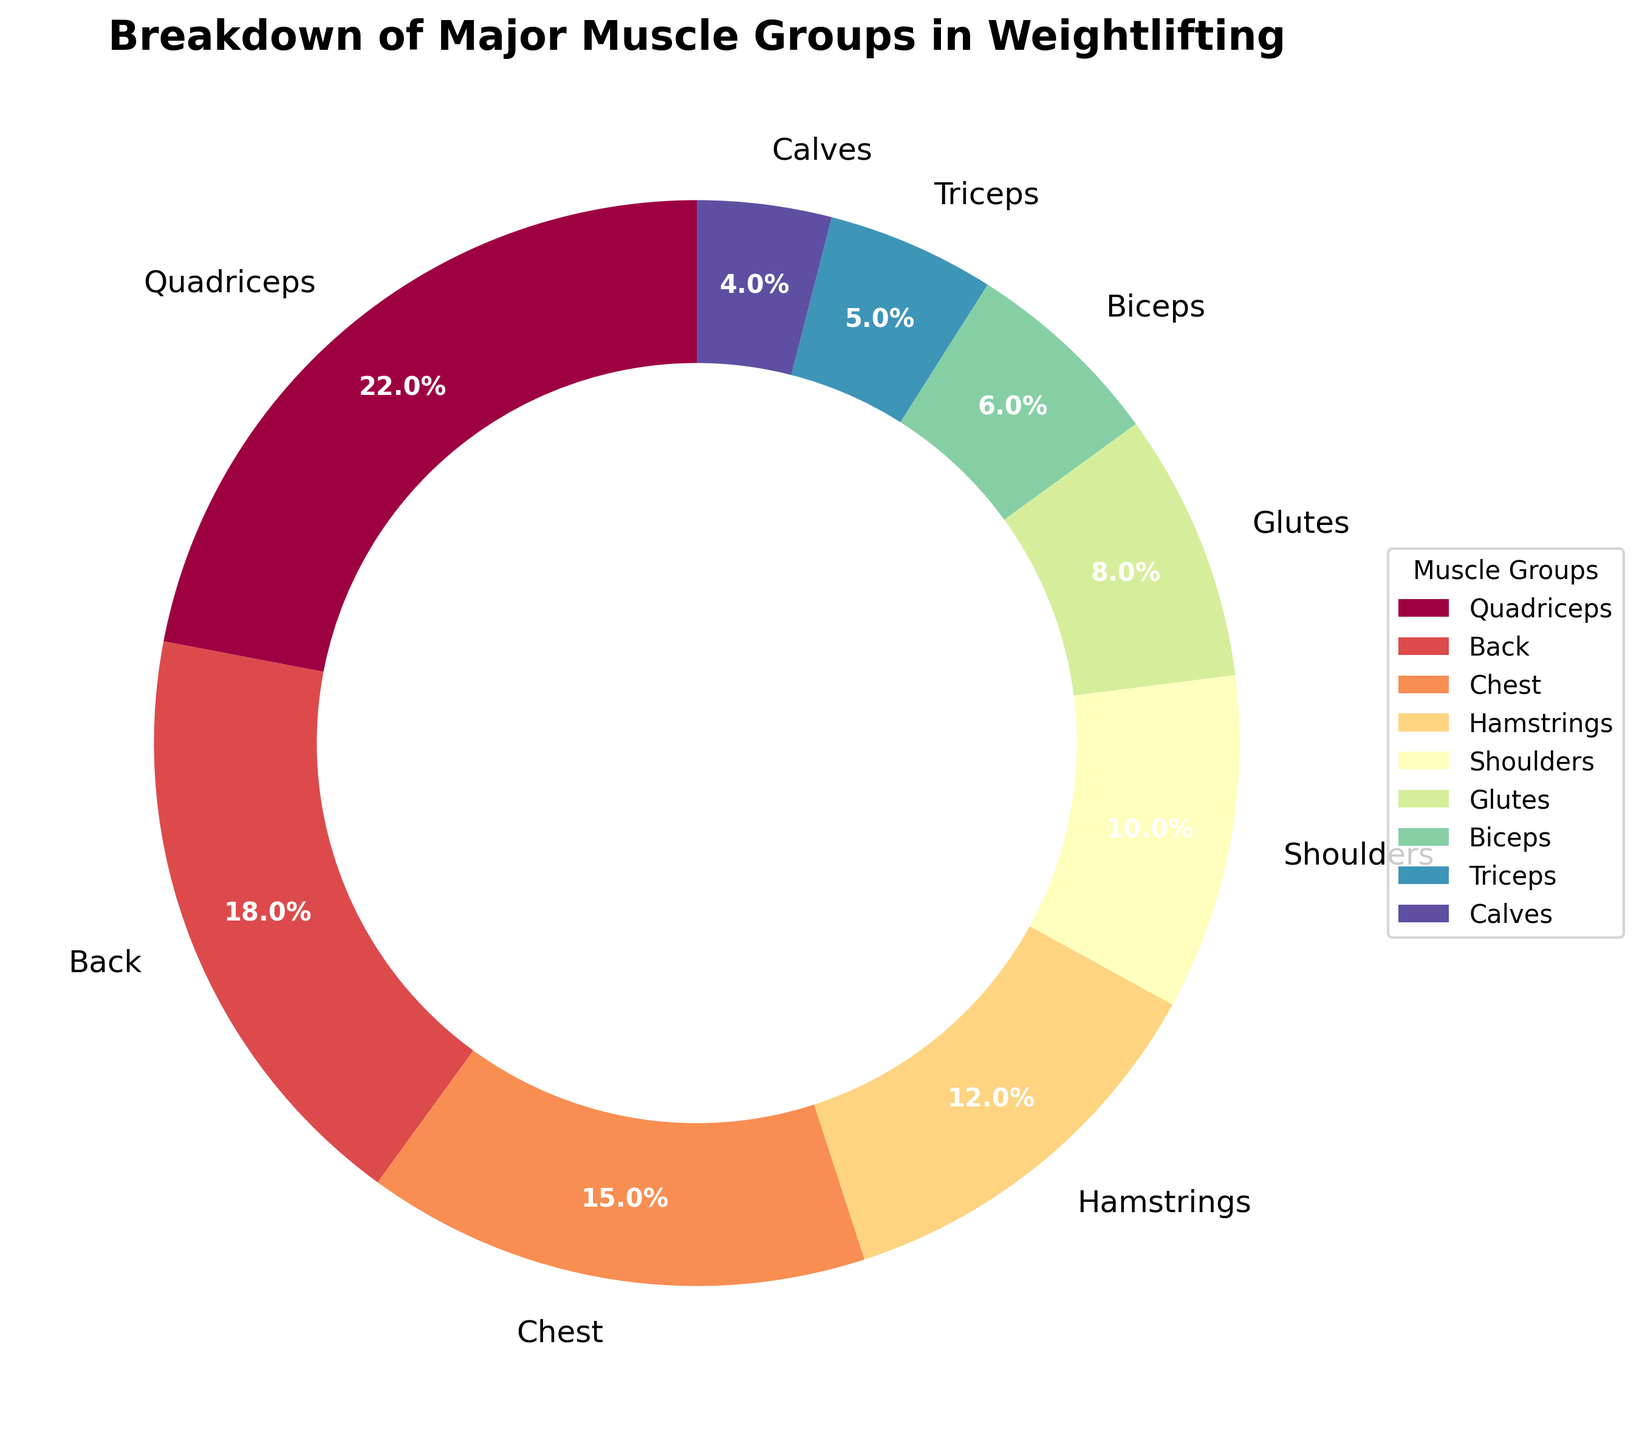Which muscle group has the highest percentage? The pie chart indicates that quadriceps have the highest percentage among the muscle groups. This is shown by both the label and the size of the respective wedge in the chart.
Answer: Quadriceps Which muscle group targets less than biceps but more than calves? The pie chart shows that triceps have a percentage of 5%, which is less than biceps (6%) and more than calves (4%).
Answer: Triceps What is the combined percentage of chest and shoulders? Adding the percentage of chest (15%) to that of shoulders (10%), we get a total of 25%.
Answer: 25% Which two muscle groups together make up exactly 22%? The pie chart shows that hamstrings (12%) and shoulders (10%) together make up 22%.
Answer: Hamstrings and Shoulders Among glutes, biceps, and calves, which muscle group has the second largest percentage? The percentages of glutes, biceps, and calves are 8%, 6%, and 4%, respectively. Thus, biceps has the second largest percentage among these three.
Answer: Biceps Is the percentage of quadriceps greater than or equal to the combined percentage of hamstrings and calves? The pie chart shows that quadriceps have 22%, while the combined percentage of hamstrings (12%) and calves (4%) is 16%. Thus, 22% is greater than 16%.
Answer: Greater than Which muscle group occupies a wedge with a visual color closest to red? The pie chart uses a colormap, and among the muscle groups, quadriceps typically appear in a color closest to red.
Answer: Quadriceps If you were to sum the percentages of the three muscle groups with the lowest values, what would the total be? The muscle groups with the lowest percentages are triceps (5%), biceps (6%), and calves (4%). Summing these up: 5% + 6% + 4% = 15%.
Answer: 15% What is the difference in percentage between the back and the chest muscle groups? The pie chart shows that the back muscle group is 18% while the chest is 15%. The difference is calculated as 18% - 15% = 3%.
Answer: 3% Which muscle groups combined make up over half of the total percentage? Considering the top percentages: quadriceps (22%), back (18%), chest (15%), and part of hamstrings (12%). Summing these: 22% + 18% + 15% = 55%, so quadriceps, back, and chest together make up this value. Adding anything above chest already exceeds 50%.
Answer: Quadriceps, Back, and Chest 